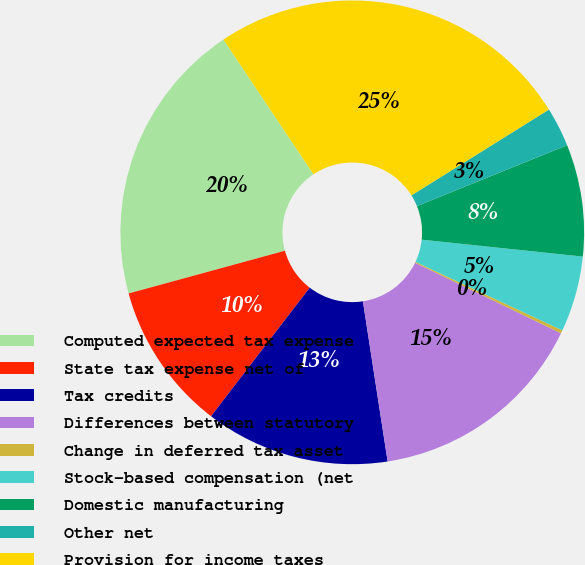<chart> <loc_0><loc_0><loc_500><loc_500><pie_chart><fcel>Computed expected tax expense<fcel>State tax expense net of<fcel>Tax credits<fcel>Differences between statutory<fcel>Change in deferred tax asset<fcel>Stock-based compensation (net<fcel>Domestic manufacturing<fcel>Other net<fcel>Provision for income taxes<nl><fcel>19.87%<fcel>10.33%<fcel>12.86%<fcel>15.39%<fcel>0.22%<fcel>5.28%<fcel>7.8%<fcel>2.75%<fcel>25.49%<nl></chart> 